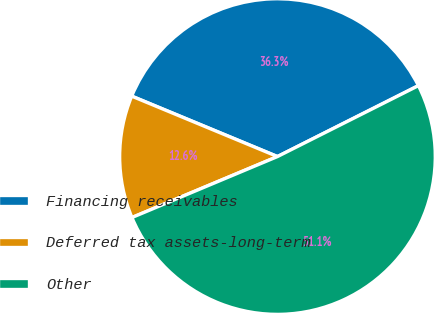Convert chart to OTSL. <chart><loc_0><loc_0><loc_500><loc_500><pie_chart><fcel>Financing receivables<fcel>Deferred tax assets-long-term<fcel>Other<nl><fcel>36.33%<fcel>12.57%<fcel>51.11%<nl></chart> 